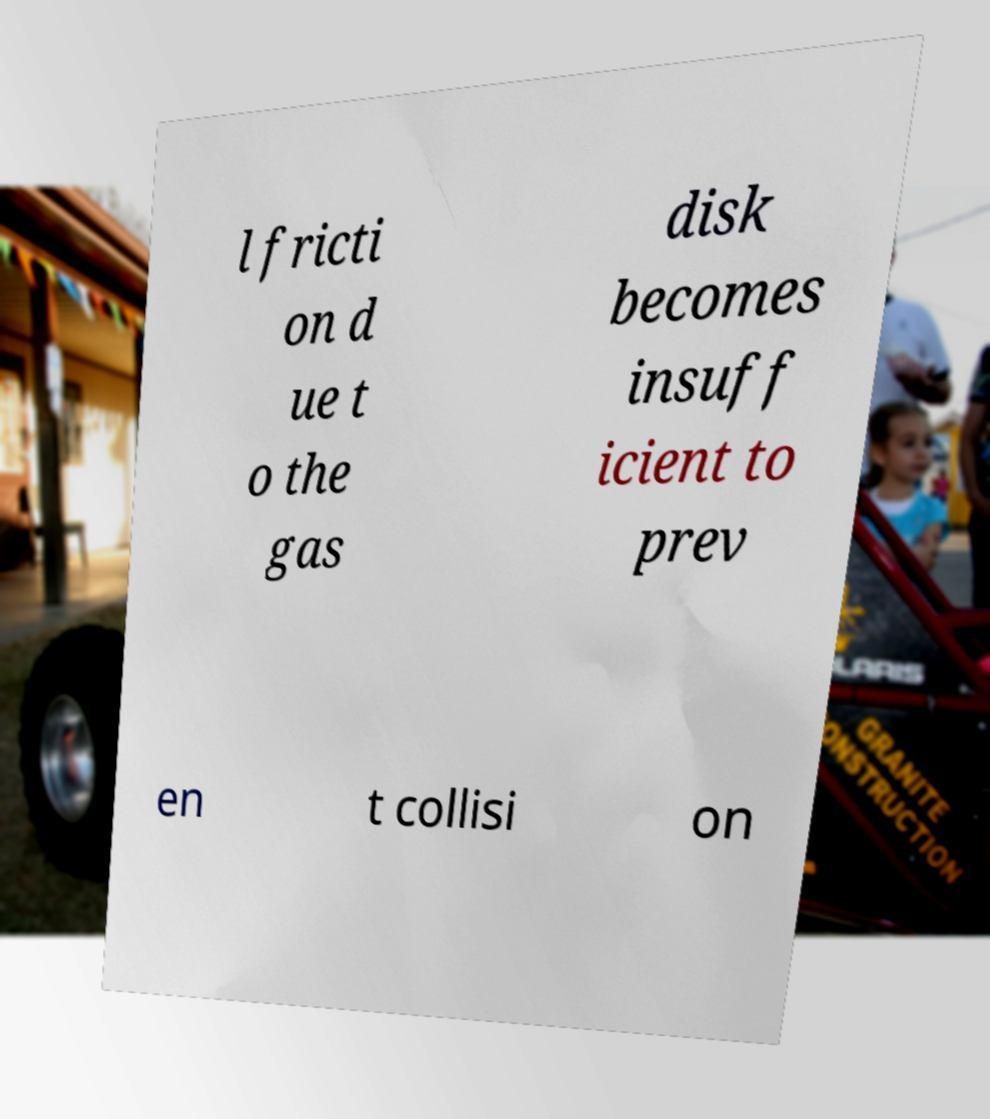There's text embedded in this image that I need extracted. Can you transcribe it verbatim? l fricti on d ue t o the gas disk becomes insuff icient to prev en t collisi on 